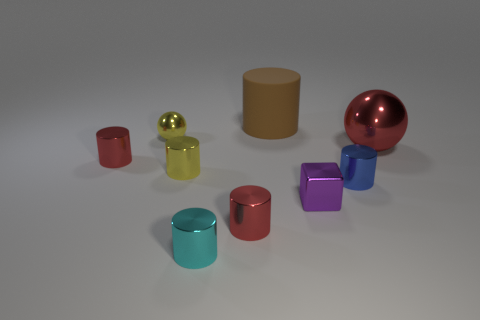Subtract all cyan cylinders. How many cylinders are left? 5 Subtract all yellow cylinders. How many cylinders are left? 5 Subtract all yellow cylinders. Subtract all red blocks. How many cylinders are left? 5 Subtract all cubes. How many objects are left? 8 Subtract all metal balls. Subtract all tiny cyan shiny cylinders. How many objects are left? 6 Add 1 red cylinders. How many red cylinders are left? 3 Add 7 tiny red metallic cylinders. How many tiny red metallic cylinders exist? 9 Subtract 0 purple cylinders. How many objects are left? 9 